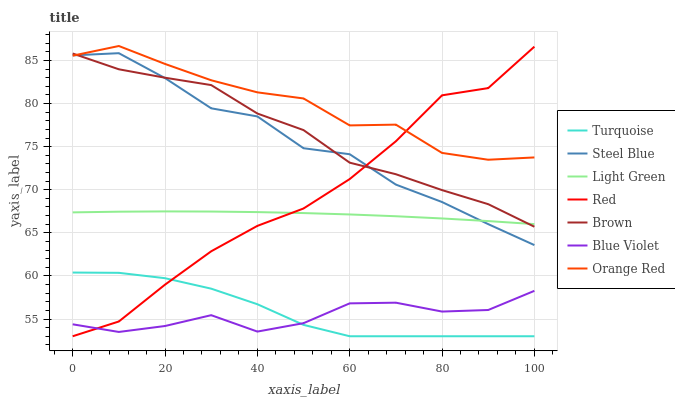Does Blue Violet have the minimum area under the curve?
Answer yes or no. Yes. Does Orange Red have the maximum area under the curve?
Answer yes or no. Yes. Does Turquoise have the minimum area under the curve?
Answer yes or no. No. Does Turquoise have the maximum area under the curve?
Answer yes or no. No. Is Light Green the smoothest?
Answer yes or no. Yes. Is Orange Red the roughest?
Answer yes or no. Yes. Is Turquoise the smoothest?
Answer yes or no. No. Is Turquoise the roughest?
Answer yes or no. No. Does Steel Blue have the lowest value?
Answer yes or no. No. Does Orange Red have the highest value?
Answer yes or no. Yes. Does Turquoise have the highest value?
Answer yes or no. No. Is Turquoise less than Light Green?
Answer yes or no. Yes. Is Steel Blue greater than Blue Violet?
Answer yes or no. Yes. Does Blue Violet intersect Red?
Answer yes or no. Yes. Is Blue Violet less than Red?
Answer yes or no. No. Is Blue Violet greater than Red?
Answer yes or no. No. Does Turquoise intersect Light Green?
Answer yes or no. No. 